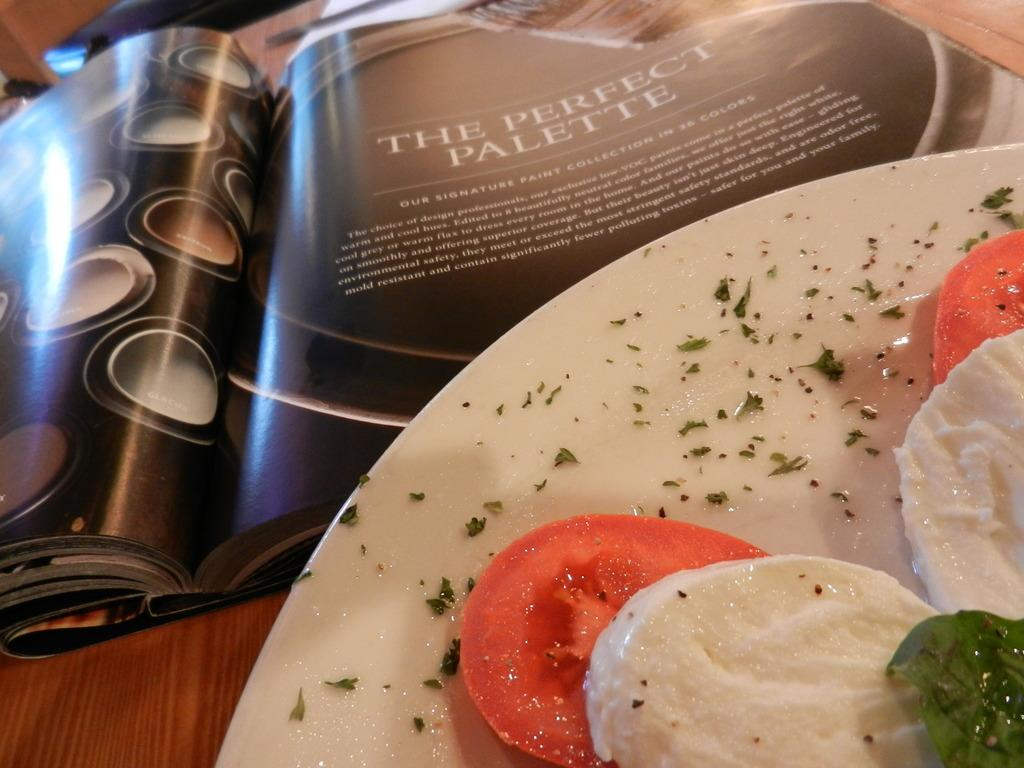What is on the plate that is visible in the image? There is a plate with food in the image. What else can be seen on the table in the image? There is a book on the table in the image. Reasoning: Let's think step by step by step in order to produce the conversation. We start by identifying the main subjects in the image, which are the plate with food and the book on the table. Then, we formulate questions that focus on the location and characteristics of these subjects, ensuring that each question can be answered definitively with the information given. We avoid yes/no questions and ensure that the language is simple and clear. Absurd Question/Answer: How many oranges are on the coast in the image? There are no oranges or coast present in the image. What does the son say about the book in the image? There is no son present in the image, and therefore no interaction with the book can be observed. 